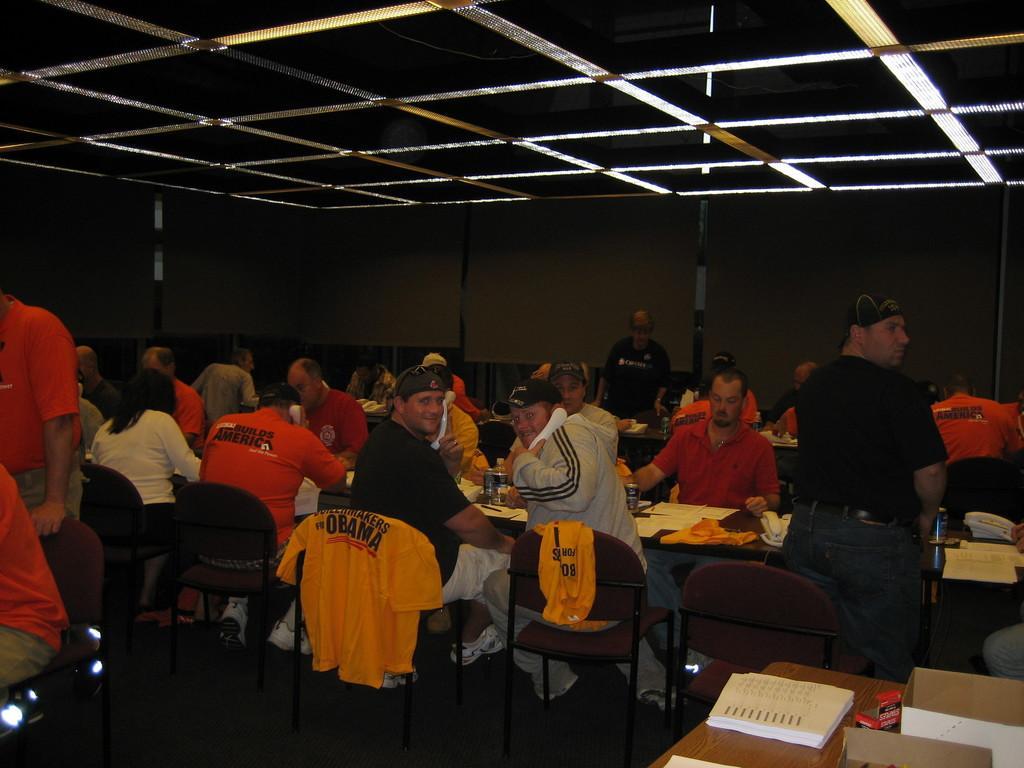Can you describe this image briefly? In the image we can see there are lot of people who are sitting on chair and few people are standing and people are wearing dress code and there are t shirts which are in orange and yellow colour and on table there is a book. 